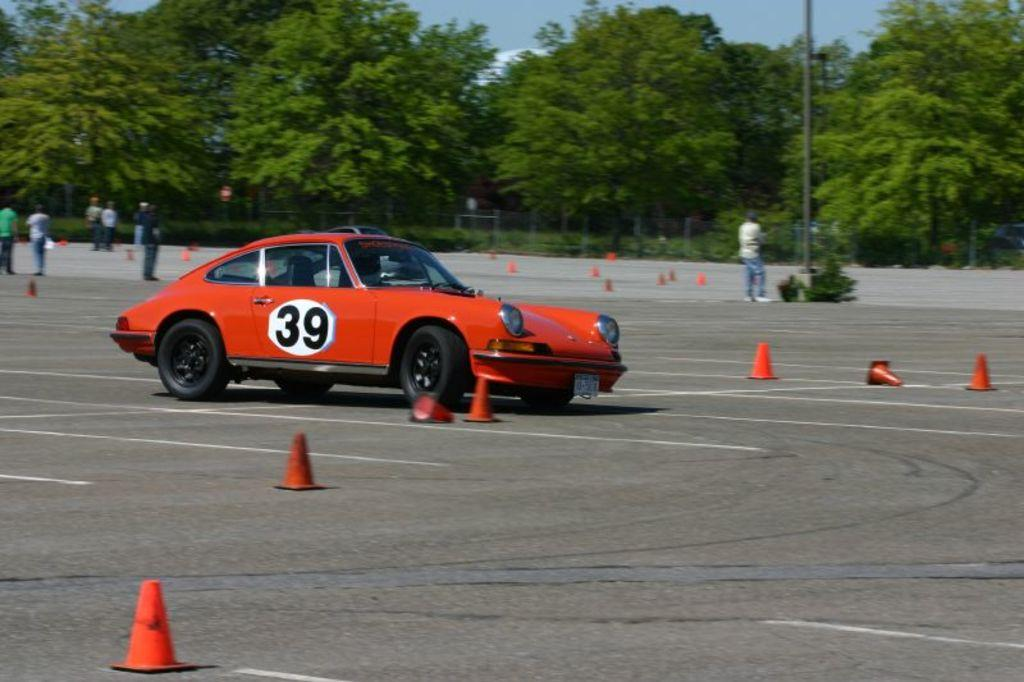What is the main subject of the image? The main subject of the image is a car. What can be seen on the road in the image? There are cones on the road in the image. What is visible in the background of the image? There are people, trees, and a pole in the background of the image. Where is the soap located in the image? There is no soap present in the image. What type of park can be seen in the background of the image? There is no park visible in the image; it features a car, cones, people, trees, and a pole in the background. 